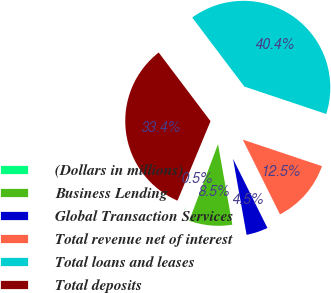<chart> <loc_0><loc_0><loc_500><loc_500><pie_chart><fcel>(Dollars in millions)<fcel>Business Lending<fcel>Global Transaction Services<fcel>Total revenue net of interest<fcel>Total loans and leases<fcel>Total deposits<nl><fcel>0.55%<fcel>8.53%<fcel>4.54%<fcel>12.51%<fcel>40.44%<fcel>33.44%<nl></chart> 